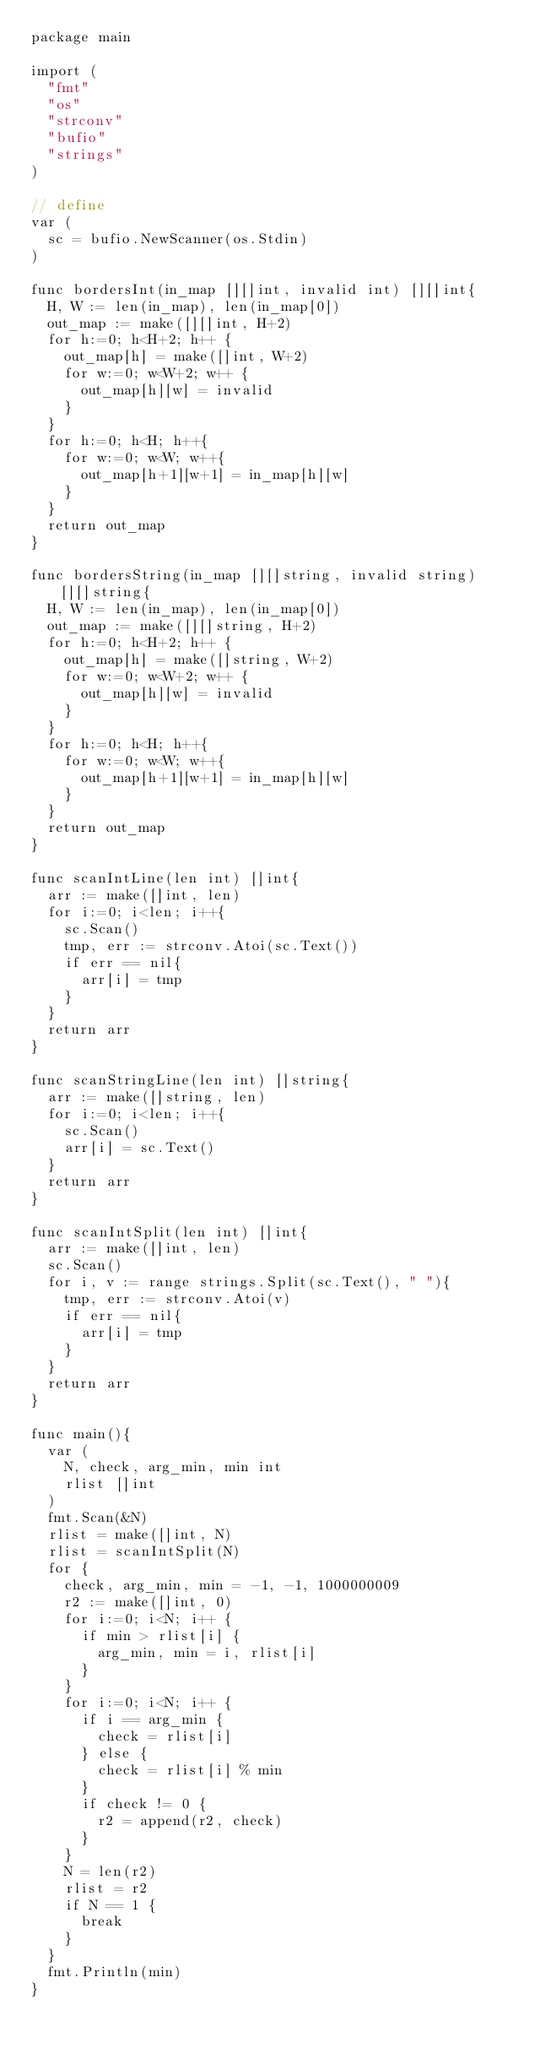<code> <loc_0><loc_0><loc_500><loc_500><_Go_>package main

import (
	"fmt"
	"os"
	"strconv"
	"bufio"
	"strings"
)

// define
var (
	sc = bufio.NewScanner(os.Stdin)
)

func bordersInt(in_map [][]int, invalid int) [][]int{
	H, W := len(in_map), len(in_map[0])
	out_map := make([][]int, H+2)
	for h:=0; h<H+2; h++ {
		out_map[h] = make([]int, W+2)
		for w:=0; w<W+2; w++ {
			out_map[h][w] = invalid
		}
	}
	for h:=0; h<H; h++{
		for w:=0; w<W; w++{
			out_map[h+1][w+1] = in_map[h][w] 
		}
	}
	return out_map
}

func bordersString(in_map [][]string, invalid string) [][]string{
	H, W := len(in_map), len(in_map[0])
	out_map := make([][]string, H+2)
	for h:=0; h<H+2; h++ {
		out_map[h] = make([]string, W+2)
		for w:=0; w<W+2; w++ {
			out_map[h][w] = invalid
		}
	}
	for h:=0; h<H; h++{
		for w:=0; w<W; w++{
			out_map[h+1][w+1] = in_map[h][w] 
		}
	}
	return out_map
}

func scanIntLine(len int) []int{
	arr := make([]int, len)
	for i:=0; i<len; i++{
		sc.Scan()
		tmp, err := strconv.Atoi(sc.Text())
		if err == nil{
			arr[i] = tmp
		}
	}
	return arr
}

func scanStringLine(len int) []string{
	arr := make([]string, len)
	for i:=0; i<len; i++{
		sc.Scan()
		arr[i] = sc.Text()
	}
	return arr
}

func scanIntSplit(len int) []int{
	arr := make([]int, len)
	sc.Scan()
	for i, v := range strings.Split(sc.Text(), " "){
		tmp, err := strconv.Atoi(v)
		if err == nil{
			arr[i] = tmp
		}
	}
	return arr
}

func main(){
	var (
		N, check, arg_min, min int
		rlist []int
	)
	fmt.Scan(&N)
	rlist = make([]int, N)
	rlist = scanIntSplit(N)
	for {
		check, arg_min, min = -1, -1, 1000000009
		r2 := make([]int, 0)
		for i:=0; i<N; i++ {
			if min > rlist[i] {
				arg_min, min = i, rlist[i]
			}
		}
		for i:=0; i<N; i++ {
			if i == arg_min {
				check = rlist[i]
			} else {
				check = rlist[i] % min
			}
			if check != 0 {
				r2 = append(r2, check)
			}
		}
		N = len(r2)
		rlist = r2
		if N == 1 {
			break
		}
	}
	fmt.Println(min)
}</code> 